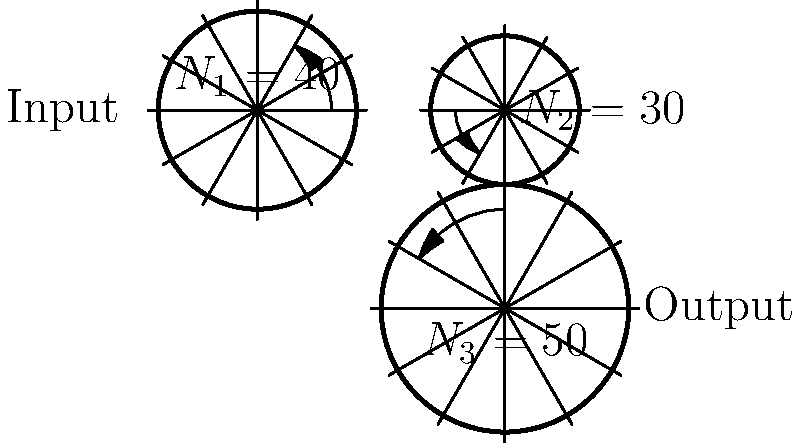In the multi-stage gear system shown above, gear 1 (input) has 40 teeth, gear 2 has 30 teeth, and gear 3 (output) has 50 teeth. If the input gear rotates at 1200 RPM, what is the speed of the output gear in RPM? How might this gear ratio affect the application of alternative therapies using mechanical devices? To solve this problem, we'll follow these steps:

1. Calculate the gear ratio between gear 1 and gear 2:
   $$\text{Ratio}_{\text{1:2}} = \frac{N_1}{N_2} = \frac{40}{30} = \frac{4}{3}$$

2. Calculate the gear ratio between gear 2 and gear 3:
   $$\text{Ratio}_{\text{2:3}} = \frac{N_2}{N_3} = \frac{30}{50} = \frac{3}{5}$$

3. Calculate the overall gear ratio:
   $$\text{Ratio}_{\text{overall}} = \text{Ratio}_{\text{1:2}} \times \text{Ratio}_{\text{2:3}} = \frac{4}{3} \times \frac{3}{5} = \frac{4}{5} = 0.8$$

4. Calculate the output speed:
   $$\text{Output Speed} = \text{Input Speed} \times \text{Ratio}_{\text{overall}}$$
   $$\text{Output Speed} = 1200 \text{ RPM} \times 0.8 = 960 \text{ RPM}$$

Regarding the application to alternative therapies:
This gear ratio results in a reduction of speed from input to output. In the context of alternative therapies, this could be beneficial for devices that require precise, slower movements. For example, in massage therapy devices, a reduced speed could allow for more controlled and gentle manipulations. Additionally, the gear system could be used in acupuncture machines or other therapeutic devices where precise control of speed and force is crucial for patient comfort and treatment efficacy.
Answer: 960 RPM 